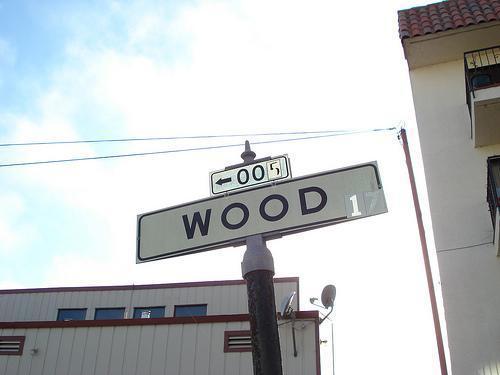How many windows are there on the building?
Give a very brief answer. 4. How many signs are there?
Give a very brief answer. 1. 